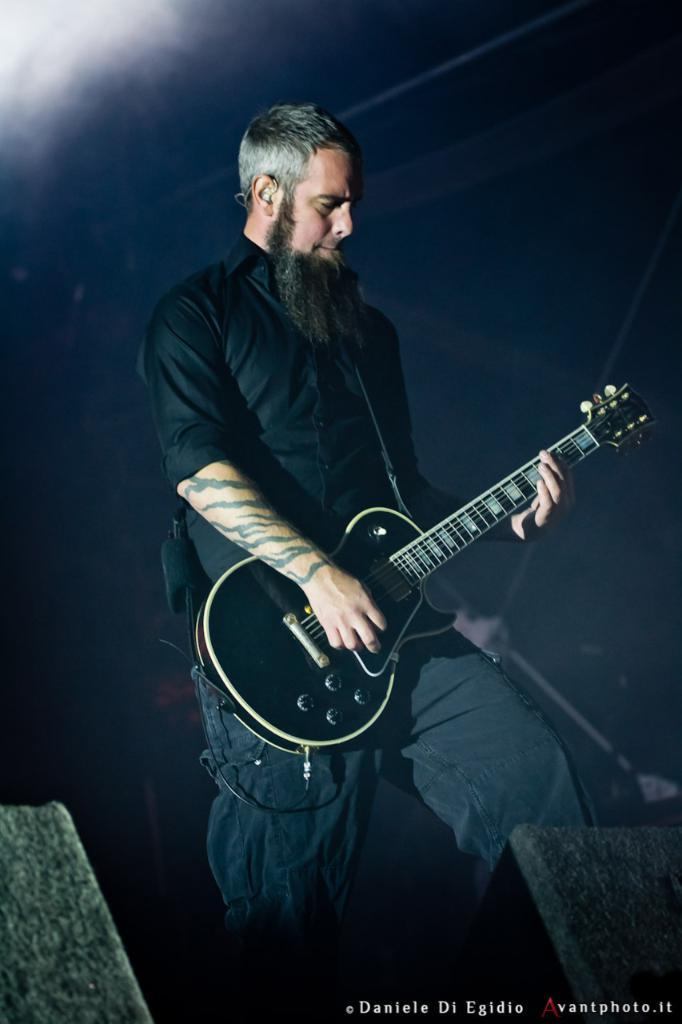What is the person in the image doing? The person is playing a guitar. What can be seen in the background of the image? There is fog in the background of the image. What type of hammer can be seen in the image? There is no hammer present in the image. How many robins are visible in the image? There are no robins present in the image. 